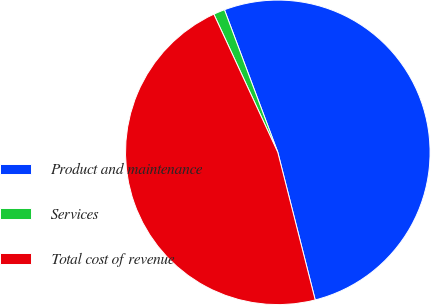Convert chart. <chart><loc_0><loc_0><loc_500><loc_500><pie_chart><fcel>Product and maintenance<fcel>Services<fcel>Total cost of revenue<nl><fcel>51.75%<fcel>1.2%<fcel>47.05%<nl></chart> 